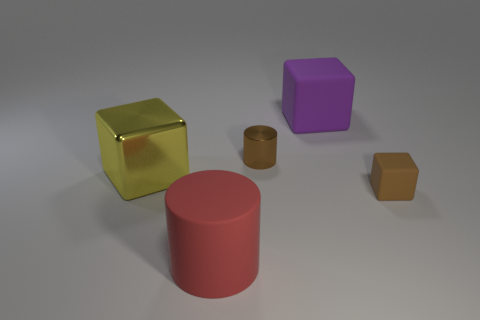What number of other things are there of the same color as the rubber cylinder?
Offer a terse response. 0. There is a object that is on the left side of the big purple object and in front of the big yellow metal object; how big is it?
Provide a succinct answer. Large. What shape is the tiny brown matte thing?
Your answer should be very brief. Cube. What number of big yellow shiny objects are the same shape as the large purple rubber thing?
Ensure brevity in your answer.  1. Are there fewer purple cubes on the left side of the large cylinder than shiny things that are left of the brown cylinder?
Your response must be concise. Yes. What number of big matte things are behind the shiny object that is right of the metal cube?
Give a very brief answer. 1. Are any blue metal blocks visible?
Your answer should be compact. No. Are there any yellow cubes made of the same material as the tiny brown cylinder?
Keep it short and to the point. Yes. Is the number of things that are to the right of the small brown metallic thing greater than the number of big things right of the large rubber cylinder?
Ensure brevity in your answer.  Yes. Do the brown rubber cube and the purple cube have the same size?
Your answer should be very brief. No. 